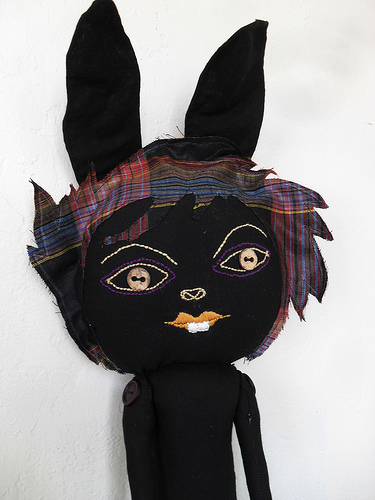<image>
Can you confirm if the stuffed animal is to the left of the wall? No. The stuffed animal is not to the left of the wall. From this viewpoint, they have a different horizontal relationship. 